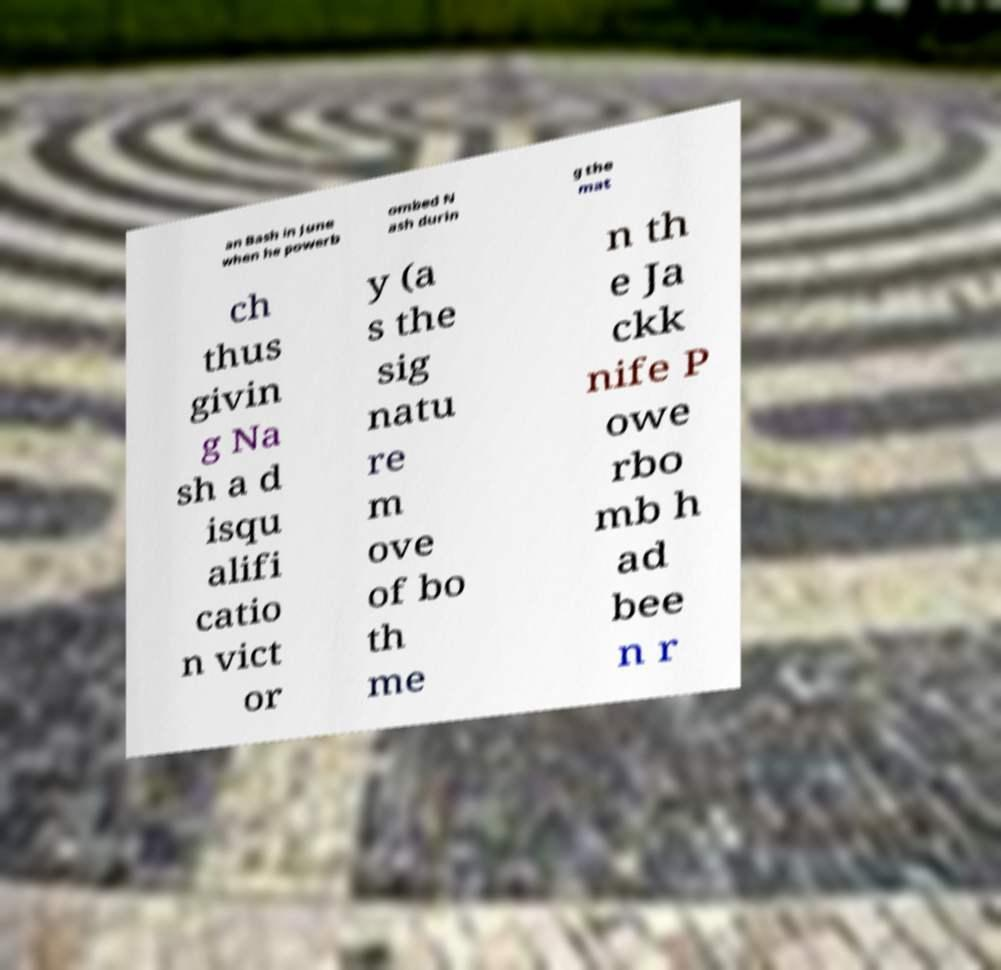What messages or text are displayed in this image? I need them in a readable, typed format. an Bash in June when he powerb ombed N ash durin g the mat ch thus givin g Na sh a d isqu alifi catio n vict or y (a s the sig natu re m ove of bo th me n th e Ja ckk nife P owe rbo mb h ad bee n r 